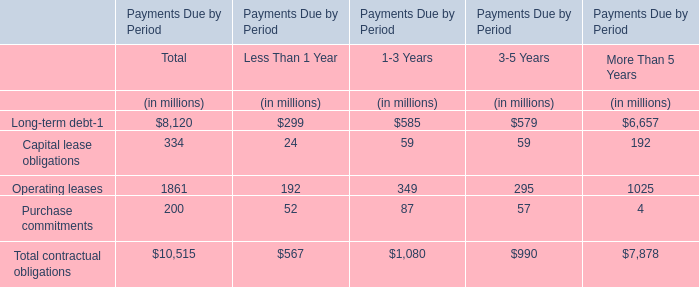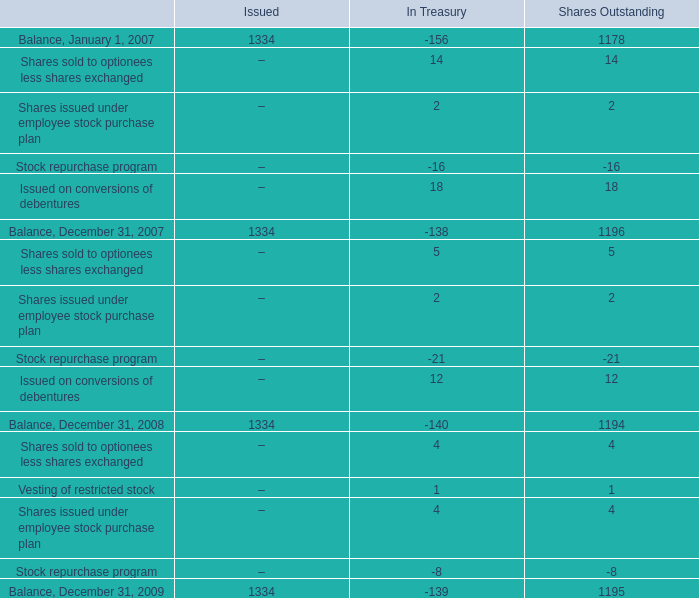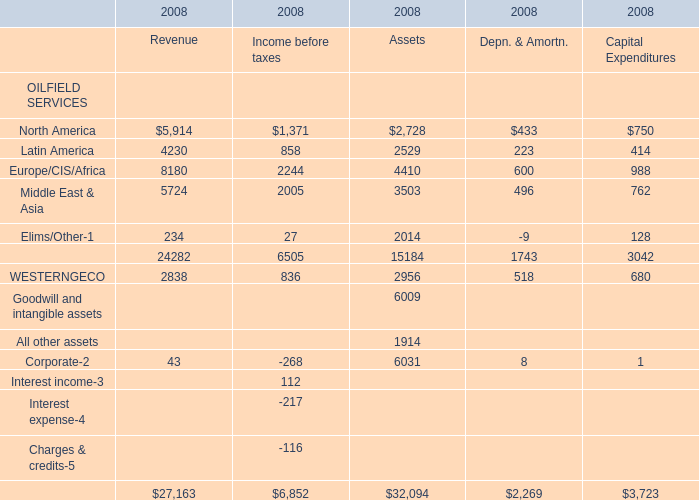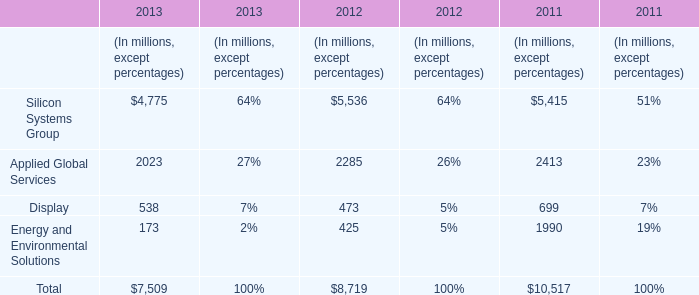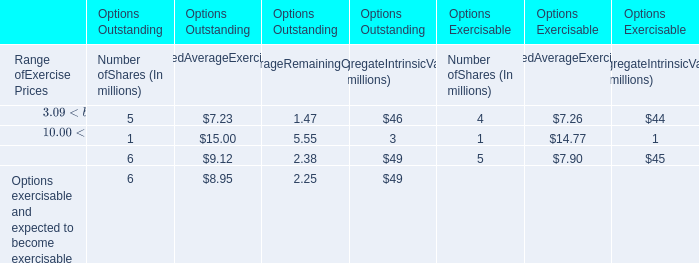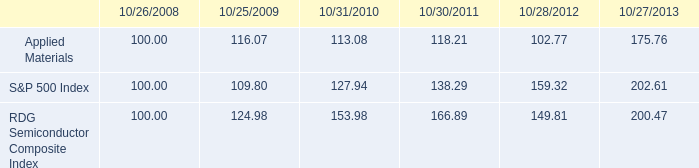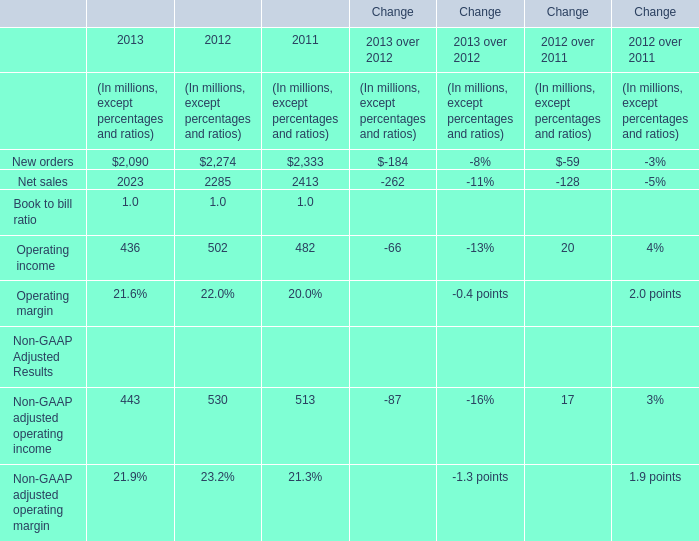In which section the sum of Europe/CIS/Africa has the highest value? 
Answer: Revenue. 